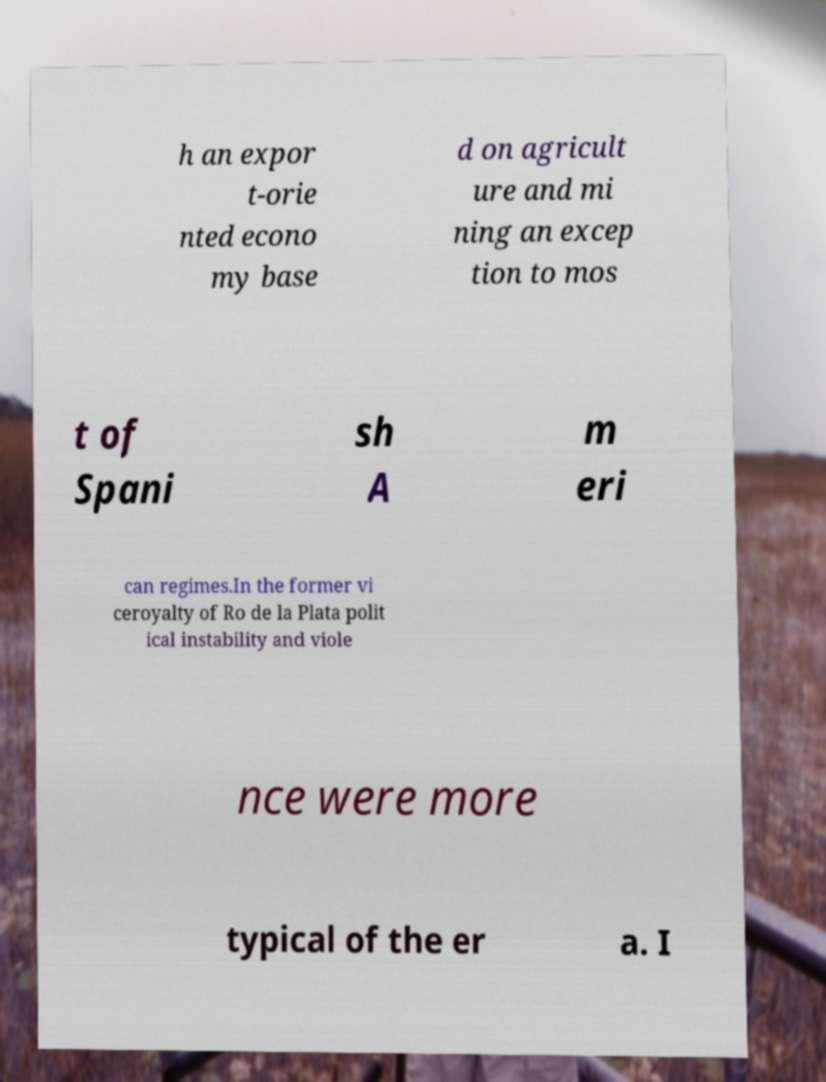Please read and relay the text visible in this image. What does it say? h an expor t-orie nted econo my base d on agricult ure and mi ning an excep tion to mos t of Spani sh A m eri can regimes.In the former vi ceroyalty of Ro de la Plata polit ical instability and viole nce were more typical of the er a. I 